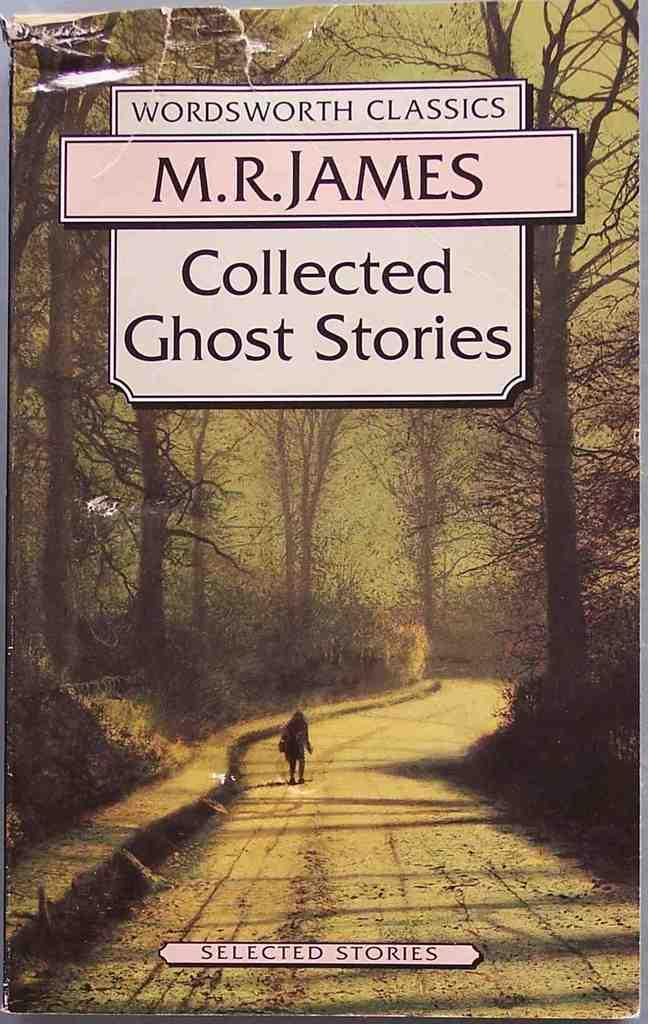<image>
Write a terse but informative summary of the picture. The book contains various ghost stories written by M.R. James. 